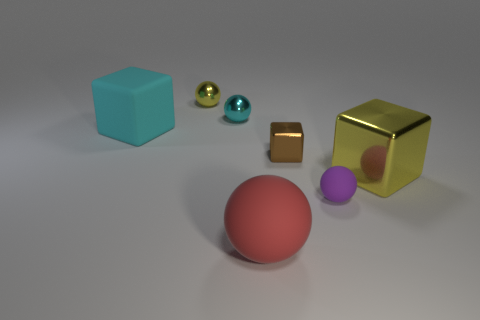Add 1 purple rubber things. How many objects exist? 8 Subtract all tiny spheres. How many spheres are left? 1 Subtract all spheres. How many objects are left? 3 Subtract all purple balls. How many balls are left? 3 Subtract 2 blocks. How many blocks are left? 1 Subtract all purple blocks. Subtract all gray balls. How many blocks are left? 3 Subtract all red blocks. How many gray spheres are left? 0 Subtract all tiny brown matte cubes. Subtract all big balls. How many objects are left? 6 Add 1 yellow spheres. How many yellow spheres are left? 2 Add 7 cyan things. How many cyan things exist? 9 